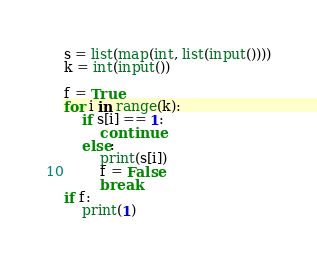<code> <loc_0><loc_0><loc_500><loc_500><_Python_>s = list(map(int, list(input())))
k = int(input())

f = True
for i in range(k):
    if s[i] == 1:
        continue
    else:
        print(s[i])
        f = False
        break
if f:
    print(1)
</code> 